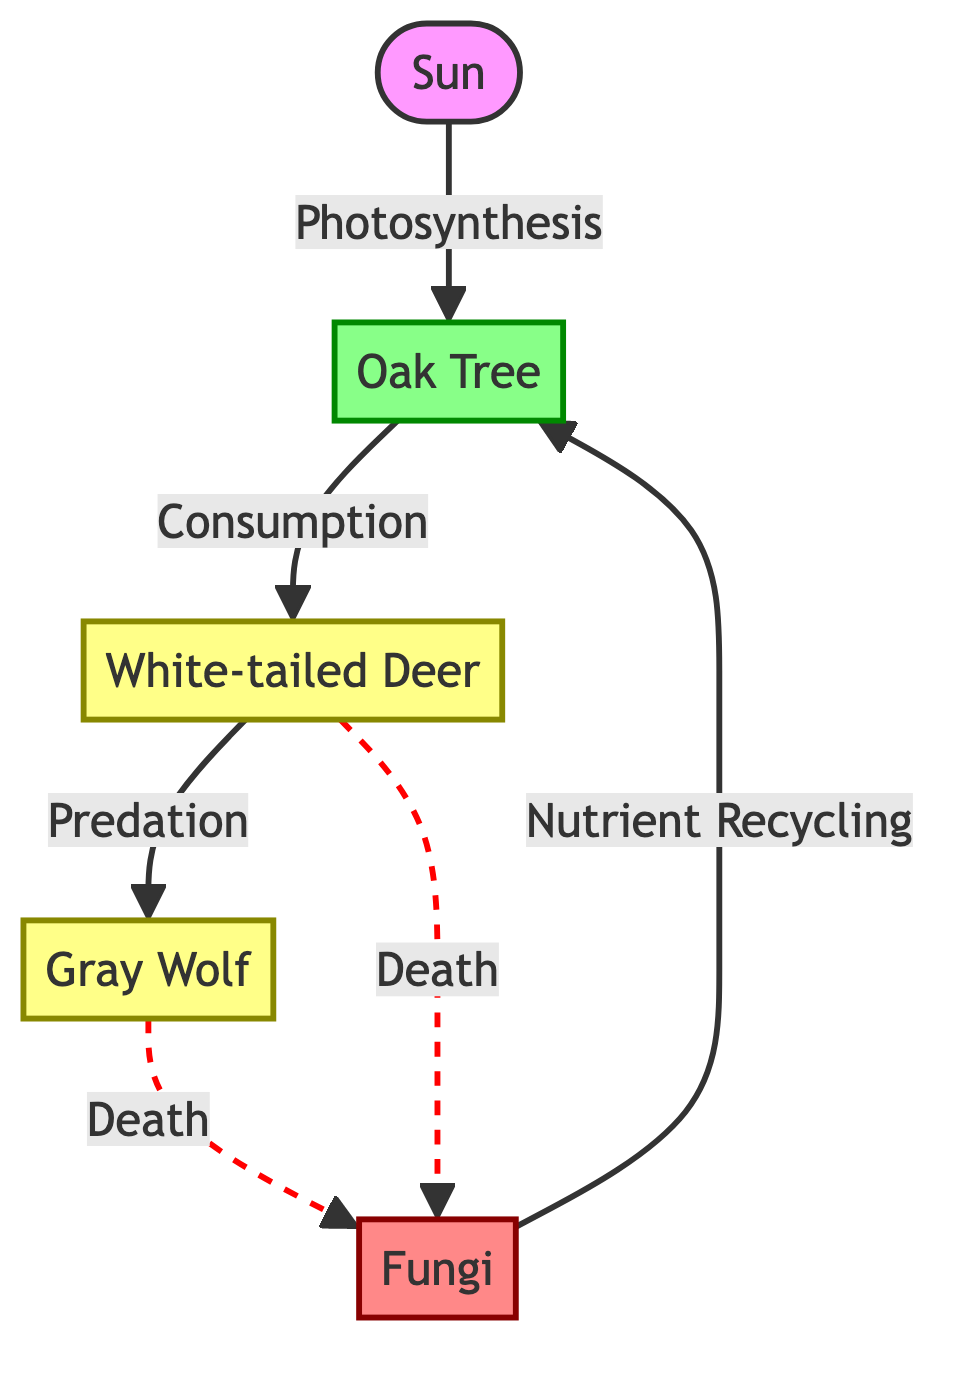What is the primary producer in this food chain? The diagram identifies the Oak Tree as the primary producer, which is the first level of the food chain where energy is captured through photosynthesis.
Answer: Oak Tree How many consumer nodes are there in the diagram? The diagram shows two consumer nodes: the White-tailed Deer and the Gray Wolf, making a total of two consumers in the food chain.
Answer: 2 What role do fungi play in this ecosystem? Fungi are labeled as decomposers in the diagram, indicating their role in breaking down organic matter and recycling nutrients back into the soil.
Answer: Decomposers Which animal is at the top of the food chain? In the diagram, the Gray Wolf is positioned above the White-tailed Deer, indicating that it is the top predator in this food chain.
Answer: Gray Wolf What process links the sun to the oak tree? The diagram indicates that the link between the sun and the oak tree is through the process of photosynthesis.
Answer: Photosynthesis How do herbivores contribute to the food chain? The diagram indicates that herbivores like the White-tailed Deer consume producers, and when they die, they become organic matter for decomposers.
Answer: Consumption What happens to the nutrients after decomposers process dead organisms? The diagram shows that after decomposers like fungi break down organic matter, they recycle nutrients back to the producers, facilitating the cycle of life in the ecosystem.
Answer: Nutrient Recycling How do carnivores fit into this food chain? The Gray Wolf, as a carnivore, preys on the herbivore (White-tailed Deer), which forms the predator-prey relationship in the food chain.
Answer: Predation What is the relationship between herbivores and decomposers? The diagram demonstrates a relationship where herbivores, upon death, provide organic matter for decomposers to break down, thus illustrating their connection in nutrient cycling.
Answer: Death 